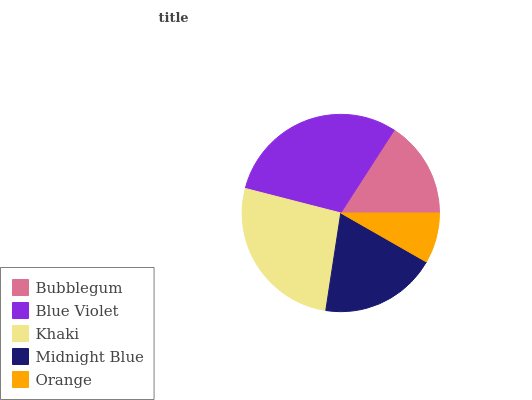Is Orange the minimum?
Answer yes or no. Yes. Is Blue Violet the maximum?
Answer yes or no. Yes. Is Khaki the minimum?
Answer yes or no. No. Is Khaki the maximum?
Answer yes or no. No. Is Blue Violet greater than Khaki?
Answer yes or no. Yes. Is Khaki less than Blue Violet?
Answer yes or no. Yes. Is Khaki greater than Blue Violet?
Answer yes or no. No. Is Blue Violet less than Khaki?
Answer yes or no. No. Is Midnight Blue the high median?
Answer yes or no. Yes. Is Midnight Blue the low median?
Answer yes or no. Yes. Is Khaki the high median?
Answer yes or no. No. Is Blue Violet the low median?
Answer yes or no. No. 